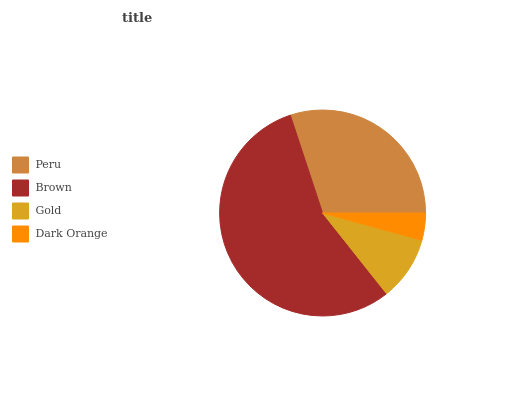Is Dark Orange the minimum?
Answer yes or no. Yes. Is Brown the maximum?
Answer yes or no. Yes. Is Gold the minimum?
Answer yes or no. No. Is Gold the maximum?
Answer yes or no. No. Is Brown greater than Gold?
Answer yes or no. Yes. Is Gold less than Brown?
Answer yes or no. Yes. Is Gold greater than Brown?
Answer yes or no. No. Is Brown less than Gold?
Answer yes or no. No. Is Peru the high median?
Answer yes or no. Yes. Is Gold the low median?
Answer yes or no. Yes. Is Gold the high median?
Answer yes or no. No. Is Peru the low median?
Answer yes or no. No. 